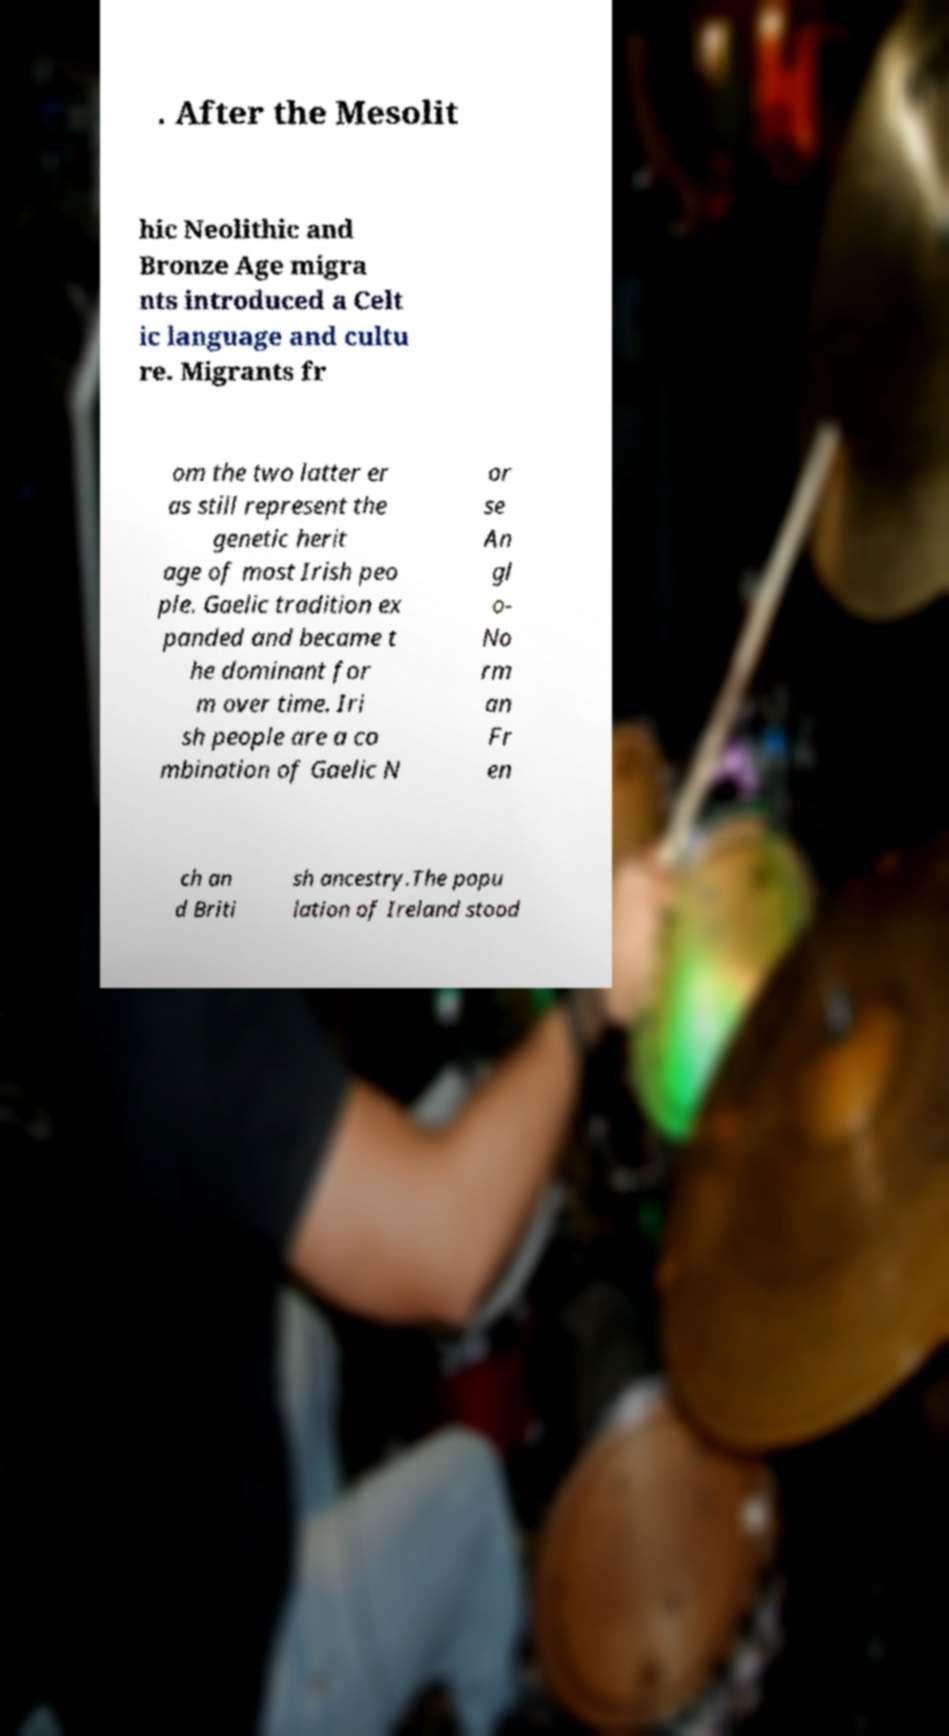I need the written content from this picture converted into text. Can you do that? . After the Mesolit hic Neolithic and Bronze Age migra nts introduced a Celt ic language and cultu re. Migrants fr om the two latter er as still represent the genetic herit age of most Irish peo ple. Gaelic tradition ex panded and became t he dominant for m over time. Iri sh people are a co mbination of Gaelic N or se An gl o- No rm an Fr en ch an d Briti sh ancestry.The popu lation of Ireland stood 